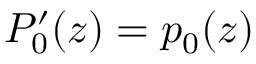<formula> <loc_0><loc_0><loc_500><loc_500>P _ { 0 } ^ { \prime } ( z ) = p _ { 0 } ( z )</formula> 